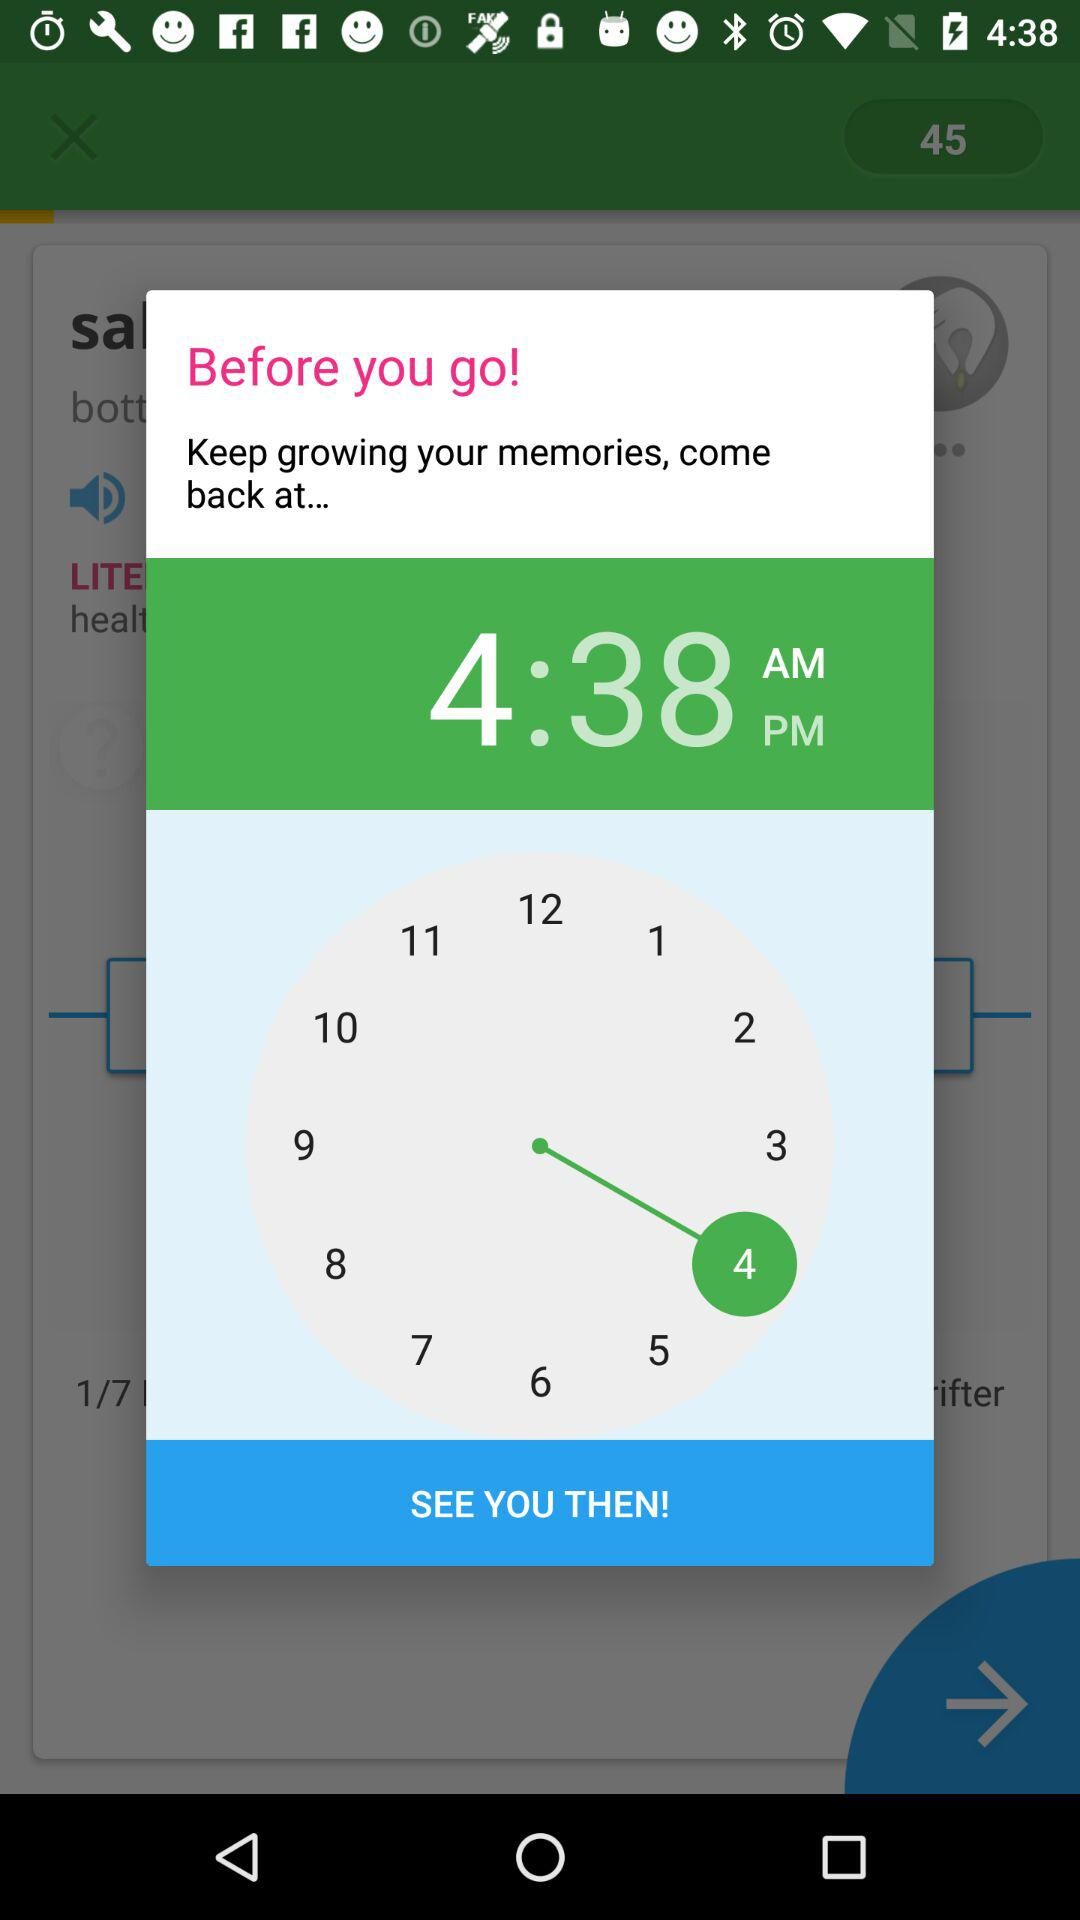What is the time? The time is 4:38 a.m. 